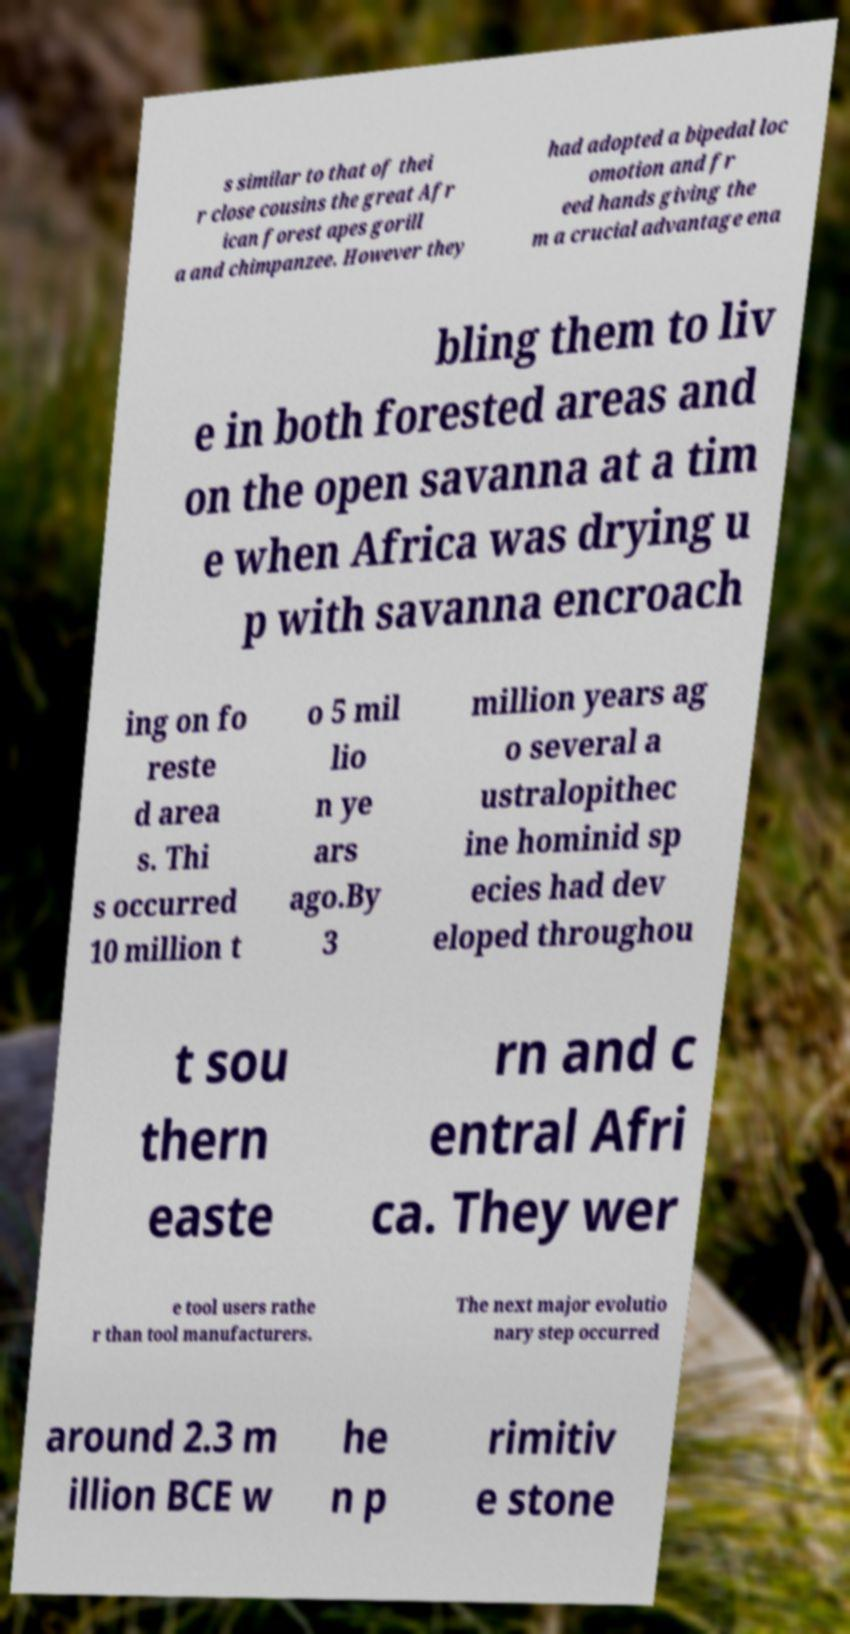Please identify and transcribe the text found in this image. s similar to that of thei r close cousins the great Afr ican forest apes gorill a and chimpanzee. However they had adopted a bipedal loc omotion and fr eed hands giving the m a crucial advantage ena bling them to liv e in both forested areas and on the open savanna at a tim e when Africa was drying u p with savanna encroach ing on fo reste d area s. Thi s occurred 10 million t o 5 mil lio n ye ars ago.By 3 million years ag o several a ustralopithec ine hominid sp ecies had dev eloped throughou t sou thern easte rn and c entral Afri ca. They wer e tool users rathe r than tool manufacturers. The next major evolutio nary step occurred around 2.3 m illion BCE w he n p rimitiv e stone 